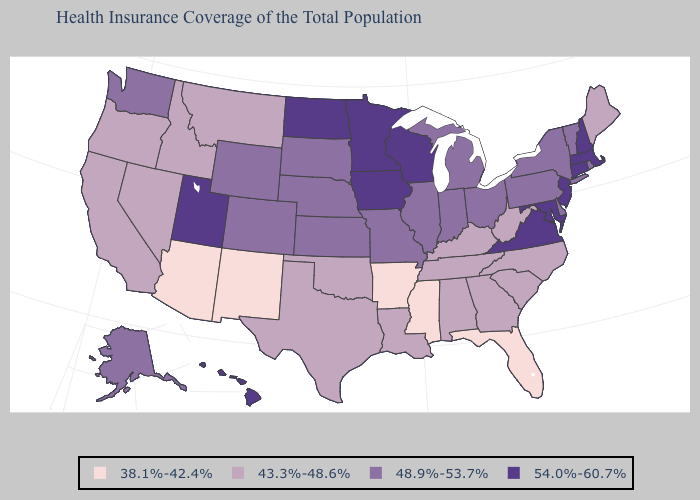What is the highest value in the MidWest ?
Answer briefly. 54.0%-60.7%. What is the lowest value in the USA?
Give a very brief answer. 38.1%-42.4%. Which states have the lowest value in the USA?
Give a very brief answer. Arizona, Arkansas, Florida, Mississippi, New Mexico. Name the states that have a value in the range 48.9%-53.7%?
Answer briefly. Alaska, Colorado, Delaware, Illinois, Indiana, Kansas, Michigan, Missouri, Nebraska, New York, Ohio, Pennsylvania, Rhode Island, South Dakota, Vermont, Washington, Wyoming. Name the states that have a value in the range 38.1%-42.4%?
Give a very brief answer. Arizona, Arkansas, Florida, Mississippi, New Mexico. Among the states that border Tennessee , which have the highest value?
Be succinct. Virginia. Does Massachusetts have the same value as Wisconsin?
Answer briefly. Yes. What is the value of California?
Short answer required. 43.3%-48.6%. Does Missouri have the highest value in the MidWest?
Quick response, please. No. How many symbols are there in the legend?
Give a very brief answer. 4. What is the lowest value in the USA?
Short answer required. 38.1%-42.4%. Is the legend a continuous bar?
Write a very short answer. No. Name the states that have a value in the range 43.3%-48.6%?
Short answer required. Alabama, California, Georgia, Idaho, Kentucky, Louisiana, Maine, Montana, Nevada, North Carolina, Oklahoma, Oregon, South Carolina, Tennessee, Texas, West Virginia. Among the states that border Minnesota , does South Dakota have the highest value?
Short answer required. No. Does the map have missing data?
Be succinct. No. 